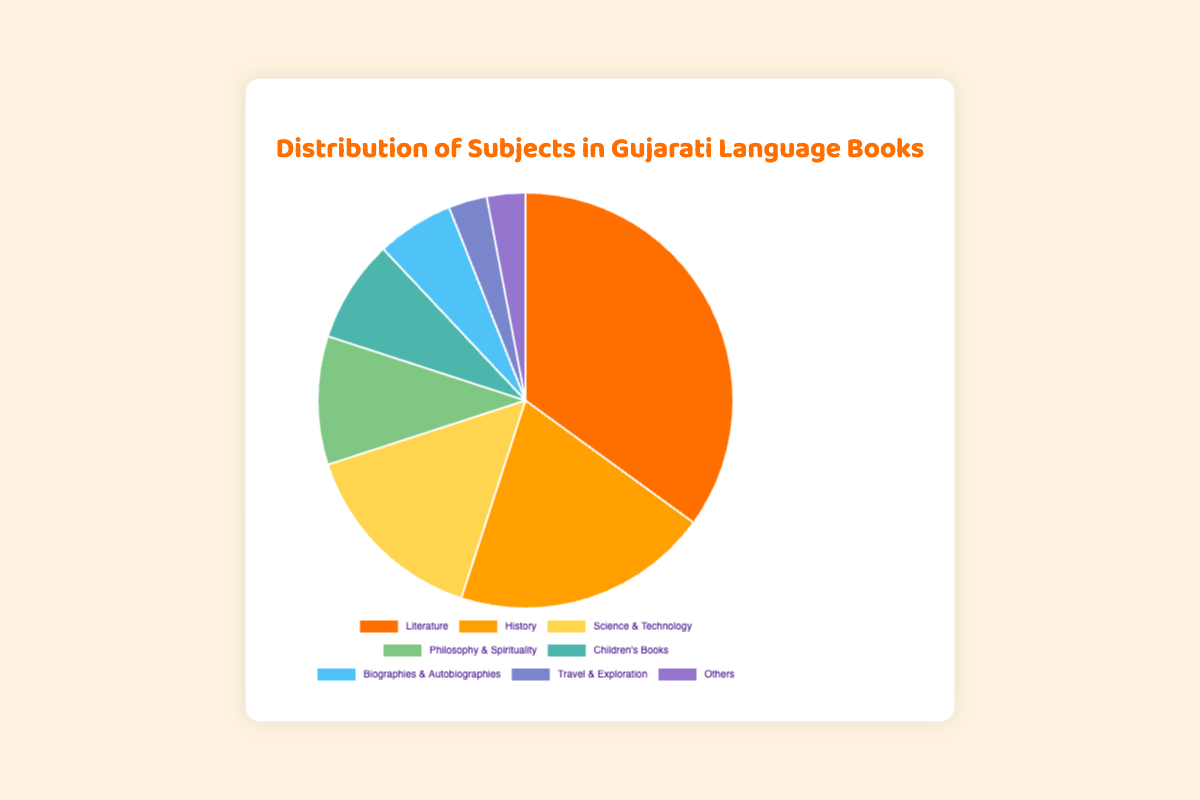What percentage of Gujarati books are Literature and History combined? The combined percentage of Literature and History is calculated by summing their individual percentages: 35% (Literature) + 20% (History) = 55%
Answer: 55% Which subject has the lowest percentage of Gujarati books? The subjects with the lowest percentage are Travel & Exploration and Others, both having 3% each
Answer: Travel & Exploration, Others How much more popular is Literature compared to Science & Technology in Gujarati books? Literature accounts for 35% while Science & Technology accounts for 15%. The difference is calculated as 35% - 15% = 20%
Answer: 20% Which color represents the Philosophy & Spirituality category in the pie chart? The Philosophy & Spirituality category is visually represented by the green color, as per the chart's color scheme
Answer: green What is the total percentage of Gujarati books that are Children's Books, Biographies & Autobiographies, and Travel & Exploration combined? The combined percentage is calculated by summing the individual percentages: 8% (Children's Books) + 6% (Biographies & Autobiographies) + 3% (Travel & Exploration) = 17%
Answer: 17% Which subject is represented by the orange color? The subject represented by the orange color is History, as per the color scheme used in the chart
Answer: History Are there more books on Science & Technology or on Philosophy & Spirituality? There are more books on Science & Technology (15%) compared to Philosophy & Spirituality (10%)
Answer: Science & Technology What is the second most popular subject in Gujarati books? The second most popular subject is History with a percentage of 20%
Answer: History What percentage of Gujarati books fall under the "Others" category? The percentage of books in the "Others" category is 3%
Answer: 3% How much less popular are Biographies & Autobiographies compared to Literature? Literature is at 35% and Biographies & Autobiographies are at 6%. The difference is calculated as 35% - 6% = 29%
Answer: 29% 